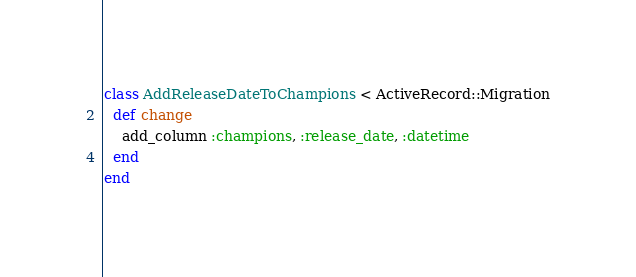<code> <loc_0><loc_0><loc_500><loc_500><_Ruby_>class AddReleaseDateToChampions < ActiveRecord::Migration
  def change
    add_column :champions, :release_date, :datetime
  end
end
</code> 